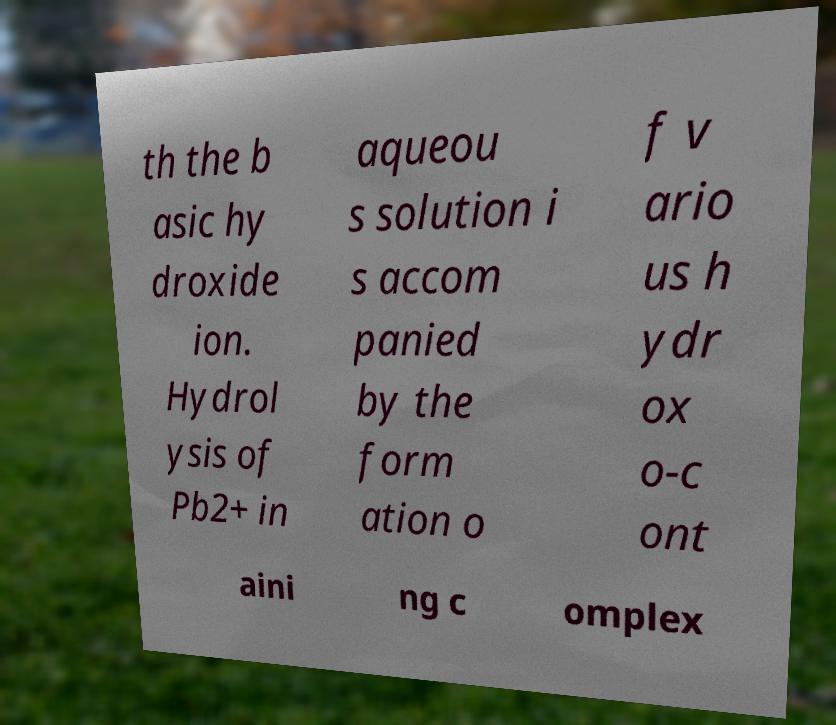Could you assist in decoding the text presented in this image and type it out clearly? th the b asic hy droxide ion. Hydrol ysis of Pb2+ in aqueou s solution i s accom panied by the form ation o f v ario us h ydr ox o-c ont aini ng c omplex 